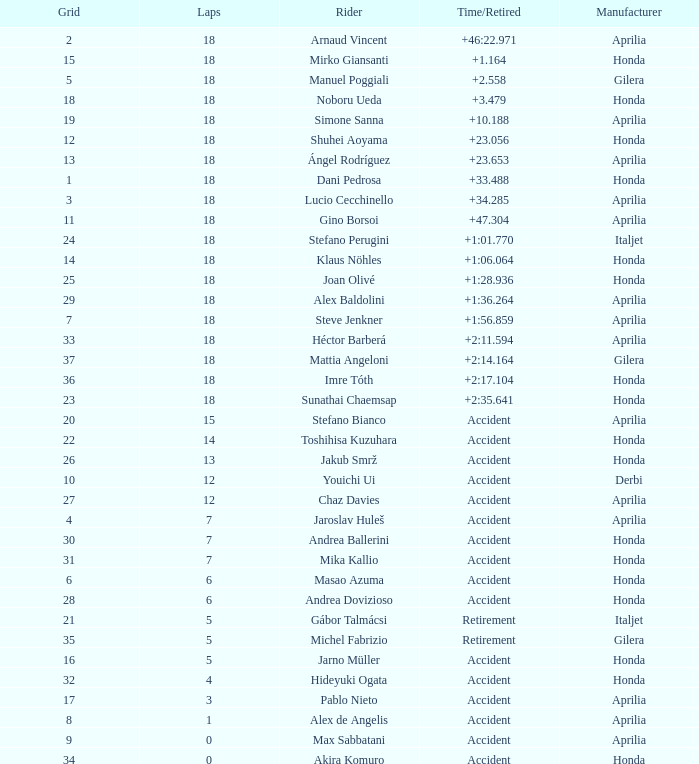Who is the rider with less than 15 laps, more than 32 grids, and an accident time/retired? Akira Komuro. 